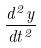Convert formula to latex. <formula><loc_0><loc_0><loc_500><loc_500>\frac { d ^ { 2 } y } { d t ^ { 2 } }</formula> 